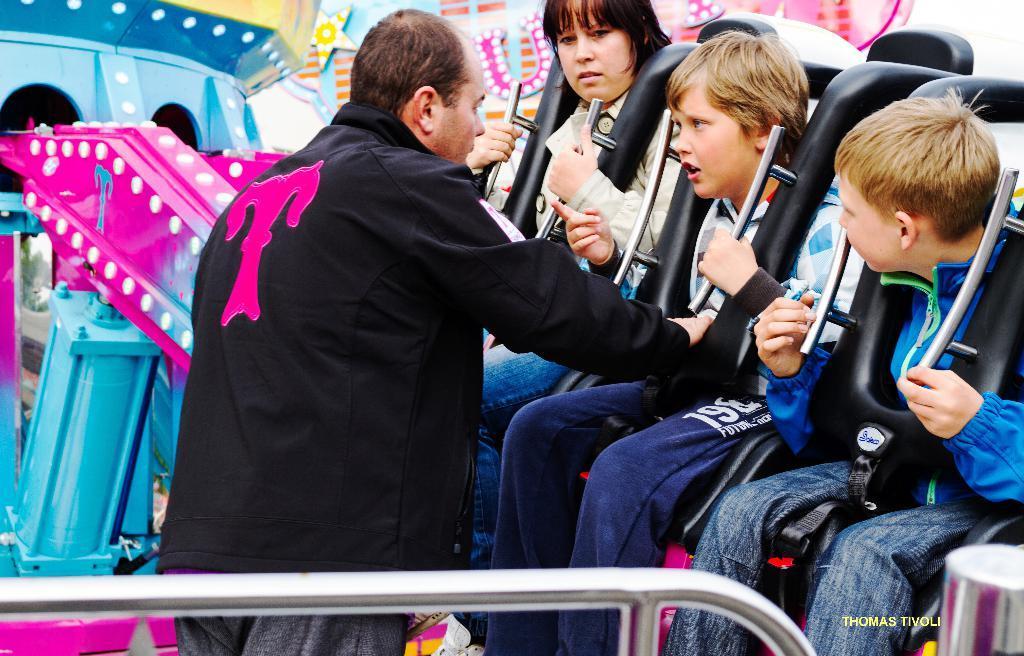Can you describe this image briefly? In this image, we can see few people. Few people are sitting on the seats of a ride and holding rods. Here a person is standing. At the bottom, we can see a silver rod. Right side bottom, we can see a watermark. 